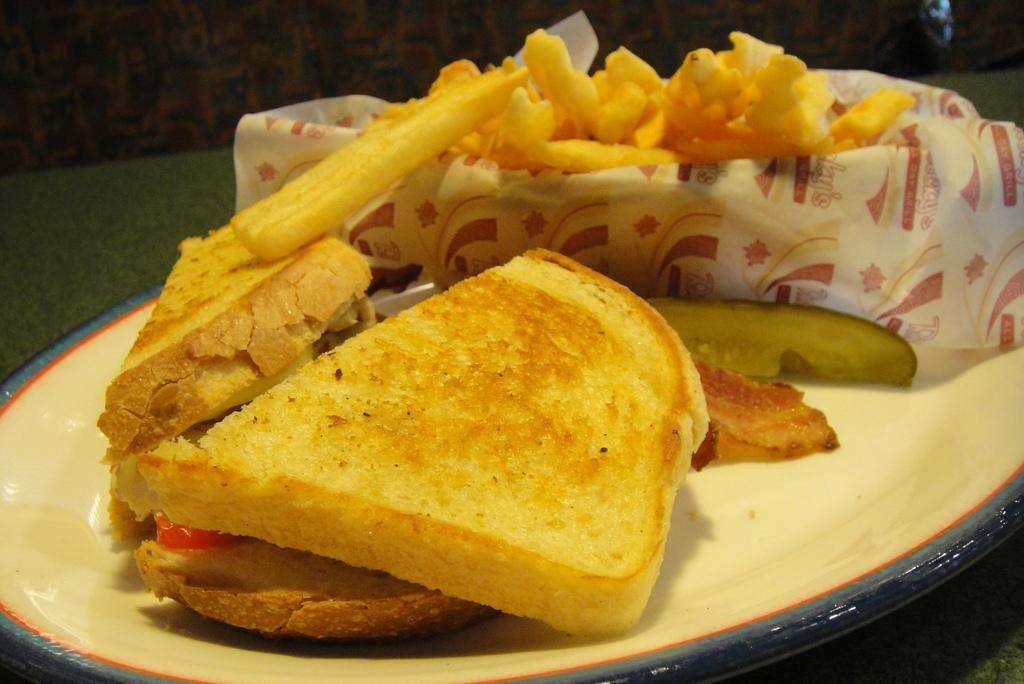Could you give a brief overview of what you see in this image? In this image, we can see some food on the plate which is on the table. 